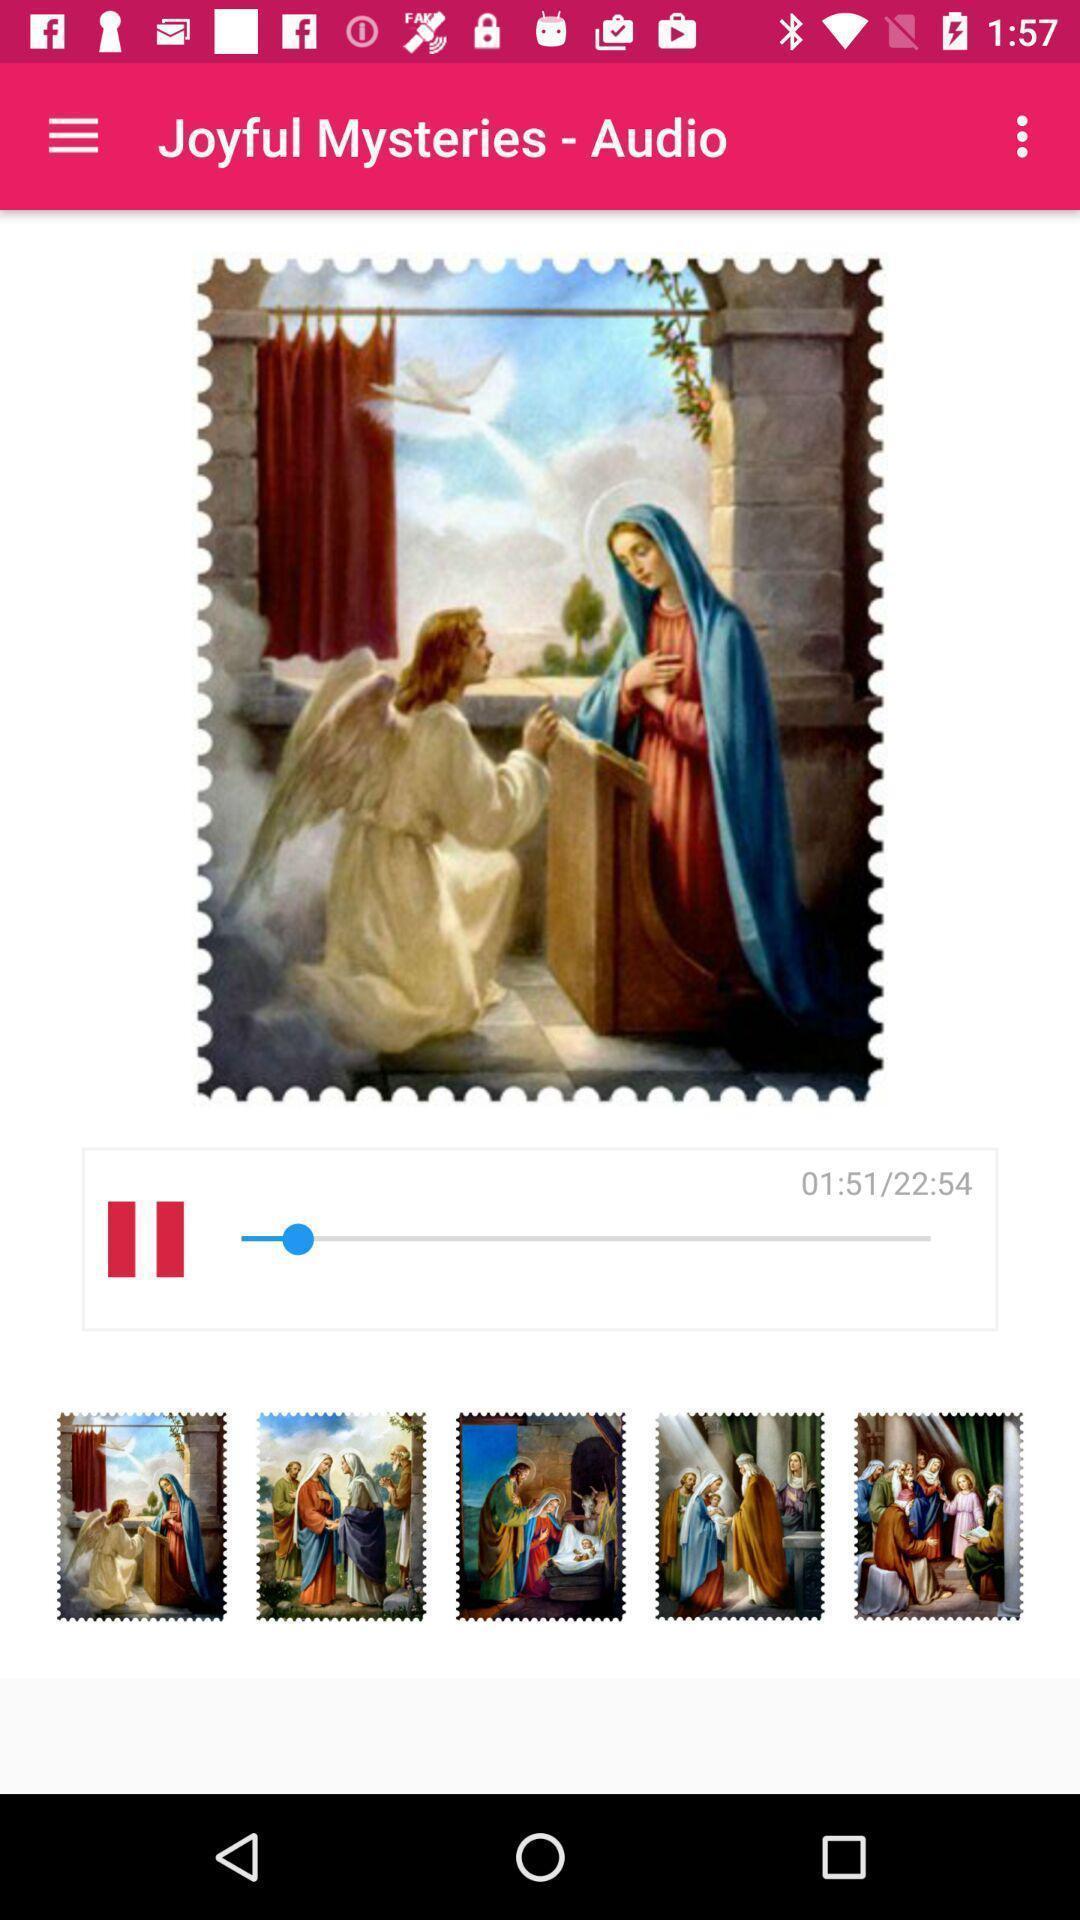What can you discern from this picture? Prayer audio is playing with background pictures. 